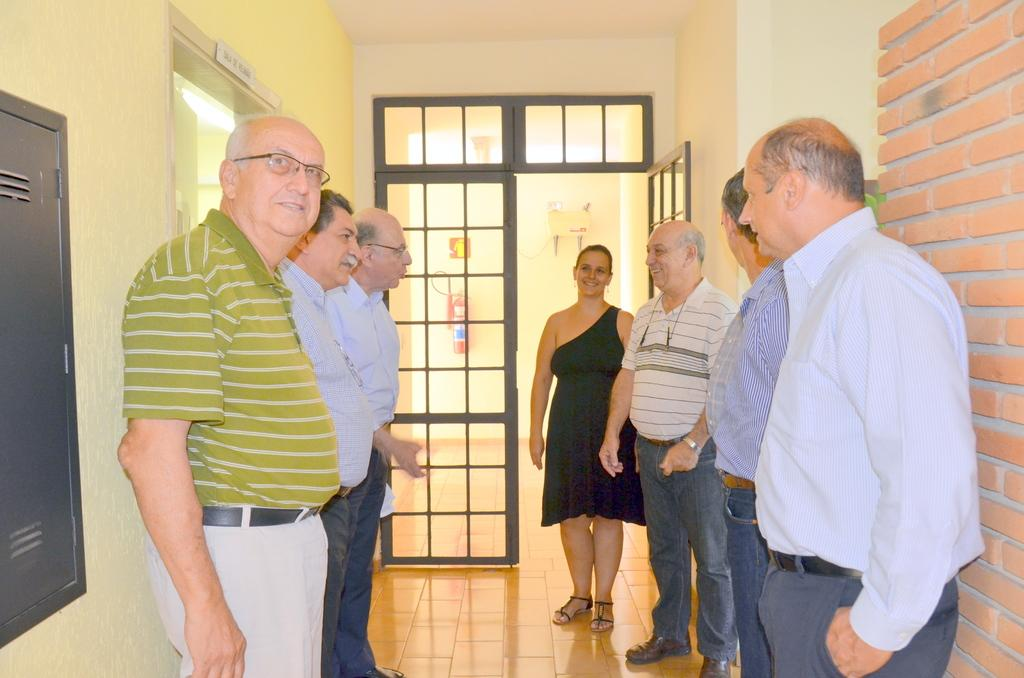What can be seen in the image involving people? There are people standing in the image. What type of structure is on the right side of the image? There is a brick wall on the right side of the image. What type of door is visible in the image? There is a glass door in the image. What color are the eyes of the brain in the image? There is no brain present in the image, and therefore no eyes or color associated with them. 